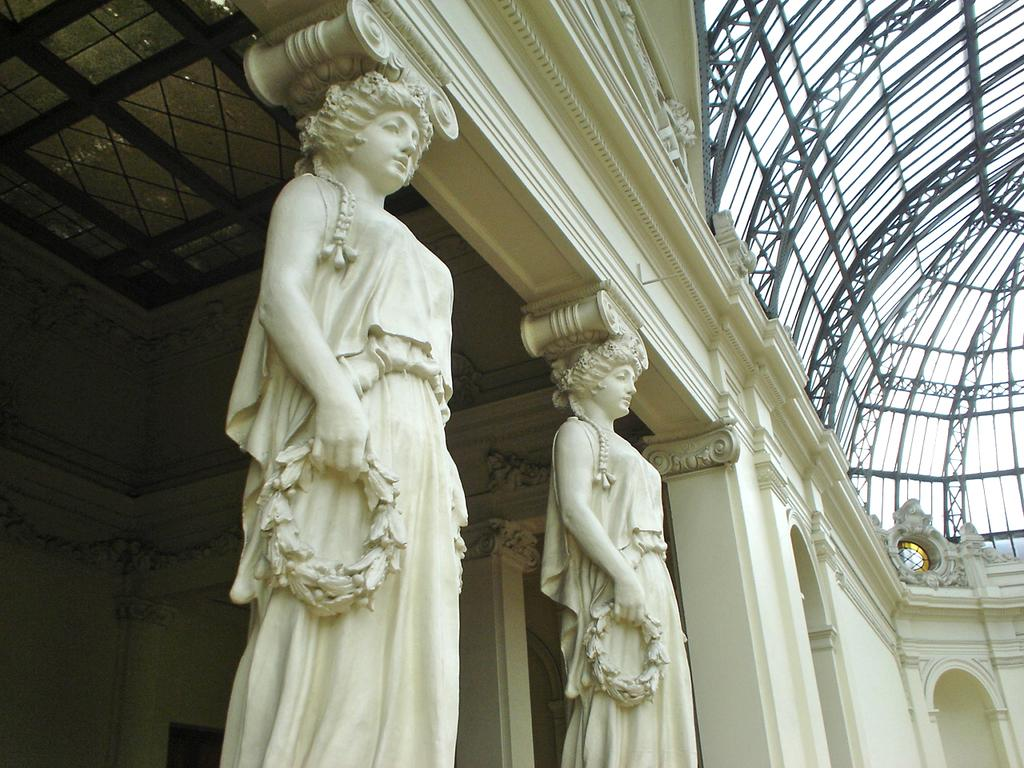What is the main structure in the image? There is a building in the image. Can you describe the rooftop of the building? The building has a metal rooftop in the right top corner. What architectural features are present in the center of the image? The building has carved pillars in the center of the image. How many worms can be seen crawling on the building in the image? There are no worms present in the image; it features a building with a metal rooftop and carved pillars. 